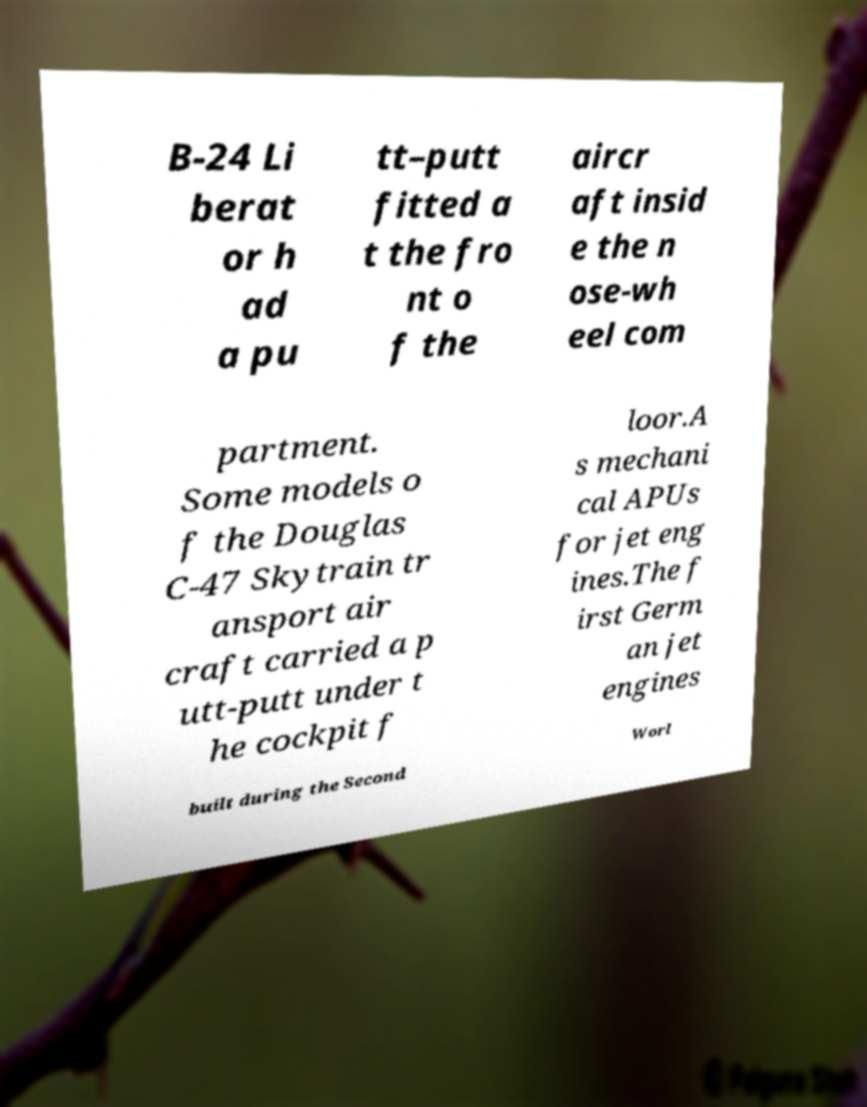Can you read and provide the text displayed in the image?This photo seems to have some interesting text. Can you extract and type it out for me? B-24 Li berat or h ad a pu tt–putt fitted a t the fro nt o f the aircr aft insid e the n ose-wh eel com partment. Some models o f the Douglas C-47 Skytrain tr ansport air craft carried a p utt-putt under t he cockpit f loor.A s mechani cal APUs for jet eng ines.The f irst Germ an jet engines built during the Second Worl 